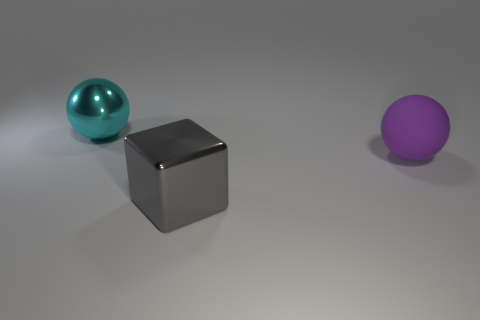What shape is the gray shiny thing that is the same size as the purple matte object?
Keep it short and to the point. Cube. The other big object that is made of the same material as the large gray thing is what color?
Your response must be concise. Cyan. There is a thing to the left of the gray metal object; what number of large gray objects are behind it?
Offer a very short reply. 0. What material is the object that is in front of the cyan object and left of the matte object?
Give a very brief answer. Metal. Does the big thing that is right of the gray metal block have the same shape as the big cyan object?
Your answer should be very brief. Yes. Is the number of metallic balls less than the number of tiny yellow metal cubes?
Keep it short and to the point. No. Are there more balls than cyan shiny spheres?
Your response must be concise. Yes. There is another rubber object that is the same shape as the cyan thing; what is its size?
Your response must be concise. Large. Is the material of the large gray cube the same as the object that is left of the gray shiny thing?
Make the answer very short. Yes. How many objects are purple matte things or small red matte balls?
Ensure brevity in your answer.  1. 